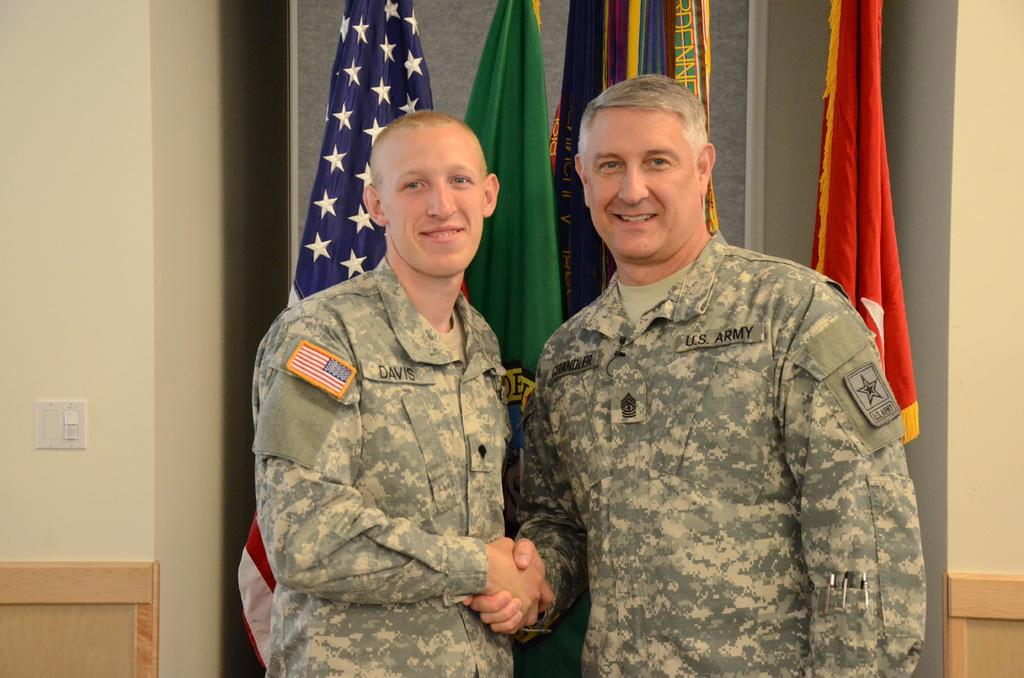How many people are in the image? There are two men in the image. What are the men doing in the image? The men are shaking hands. What can be seen in the background of the image? There are flags, a wall, and a switchboard in the background of the image. What type of government is represented by the locket in the image? There is no locket present in the image, so it is not possible to determine the type of government represented. 